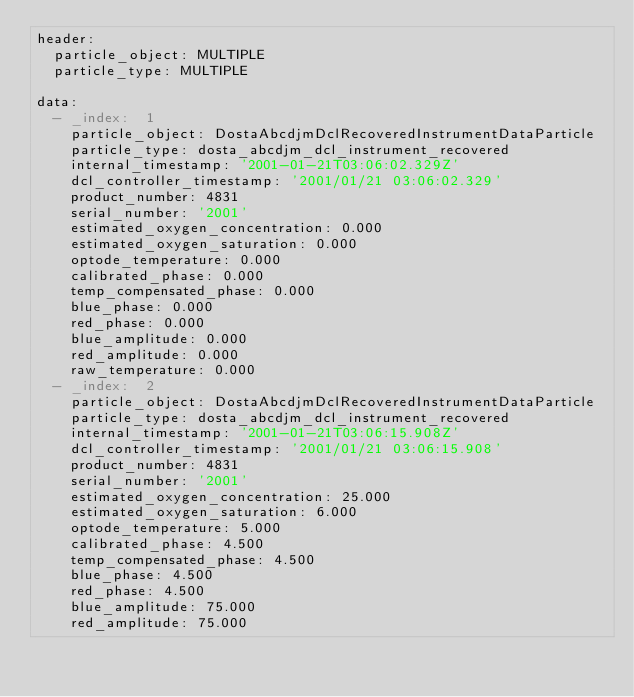<code> <loc_0><loc_0><loc_500><loc_500><_YAML_>header:
  particle_object: MULTIPLE
  particle_type: MULTIPLE

data:
  - _index:  1
    particle_object: DostaAbcdjmDclRecoveredInstrumentDataParticle
    particle_type: dosta_abcdjm_dcl_instrument_recovered
    internal_timestamp: '2001-01-21T03:06:02.329Z'
    dcl_controller_timestamp: '2001/01/21 03:06:02.329'
    product_number: 4831
    serial_number: '2001'
    estimated_oxygen_concentration: 0.000
    estimated_oxygen_saturation: 0.000
    optode_temperature: 0.000
    calibrated_phase: 0.000
    temp_compensated_phase: 0.000
    blue_phase: 0.000
    red_phase: 0.000
    blue_amplitude: 0.000
    red_amplitude: 0.000
    raw_temperature: 0.000
  - _index:  2
    particle_object: DostaAbcdjmDclRecoveredInstrumentDataParticle
    particle_type: dosta_abcdjm_dcl_instrument_recovered
    internal_timestamp: '2001-01-21T03:06:15.908Z'
    dcl_controller_timestamp: '2001/01/21 03:06:15.908'
    product_number: 4831
    serial_number: '2001'
    estimated_oxygen_concentration: 25.000
    estimated_oxygen_saturation: 6.000
    optode_temperature: 5.000
    calibrated_phase: 4.500
    temp_compensated_phase: 4.500
    blue_phase: 4.500
    red_phase: 4.500
    blue_amplitude: 75.000
    red_amplitude: 75.000</code> 